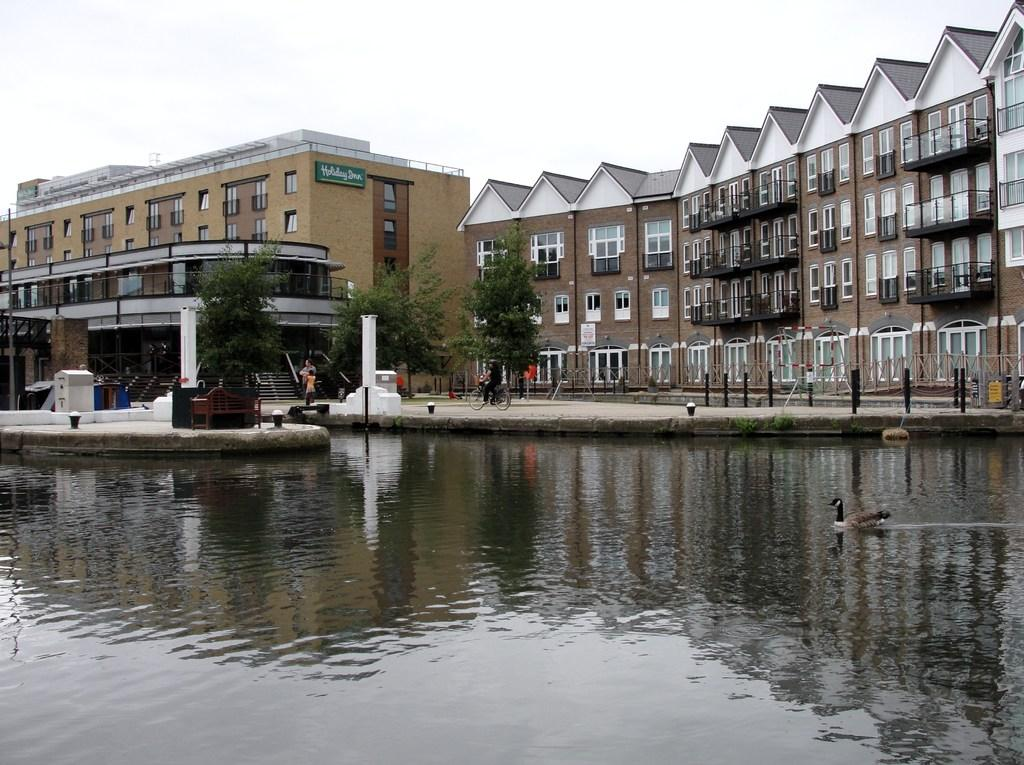What is the bird doing in the image? The bird is on the water in the image. What type of structures can be seen in the image? There are buildings visible in the image. What type of vegetation is present in the image? Trees are present in the image. Can you describe the people in the image? There are people in the image. What mode of transportation is visible in the image? A bicycle is visible in the image. What type of objects can be seen in the image? There are poles in the image, and other objects are also present. What can be seen in the background of the image? The sky is visible in the background of the image. What type of advertisement is being displayed by the bird in the image? There is no advertisement being displayed by the bird in the image; it is simply a bird on the water. What behavior is the porter exhibiting in the image? There is no porter present in the image, so it is not possible to describe their behavior. 